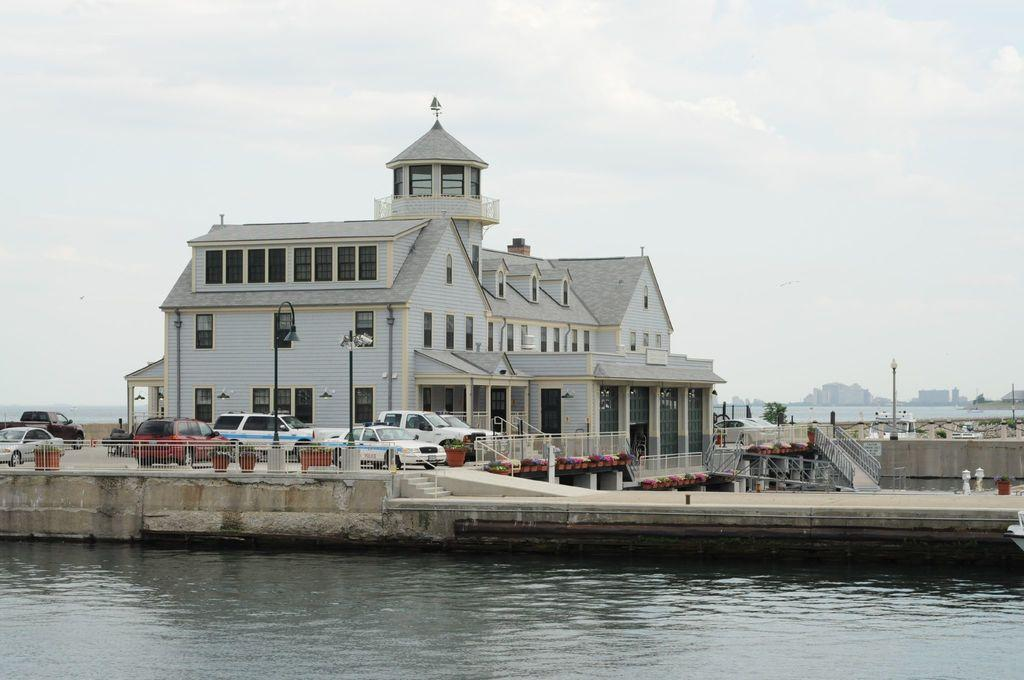What type of structure is present in the image? There is a building in the image. What feature can be seen on the building? The building has windows. What else can be seen in the image besides the building? There are many vehicles, a pole, a fence, a tree, water, stairs, and a cloudy sky visible in the image. What type of toothbrush is used by the owner of the building in the image? There is no toothbrush or owner mentioned in the image, so it is not possible to answer that question. 